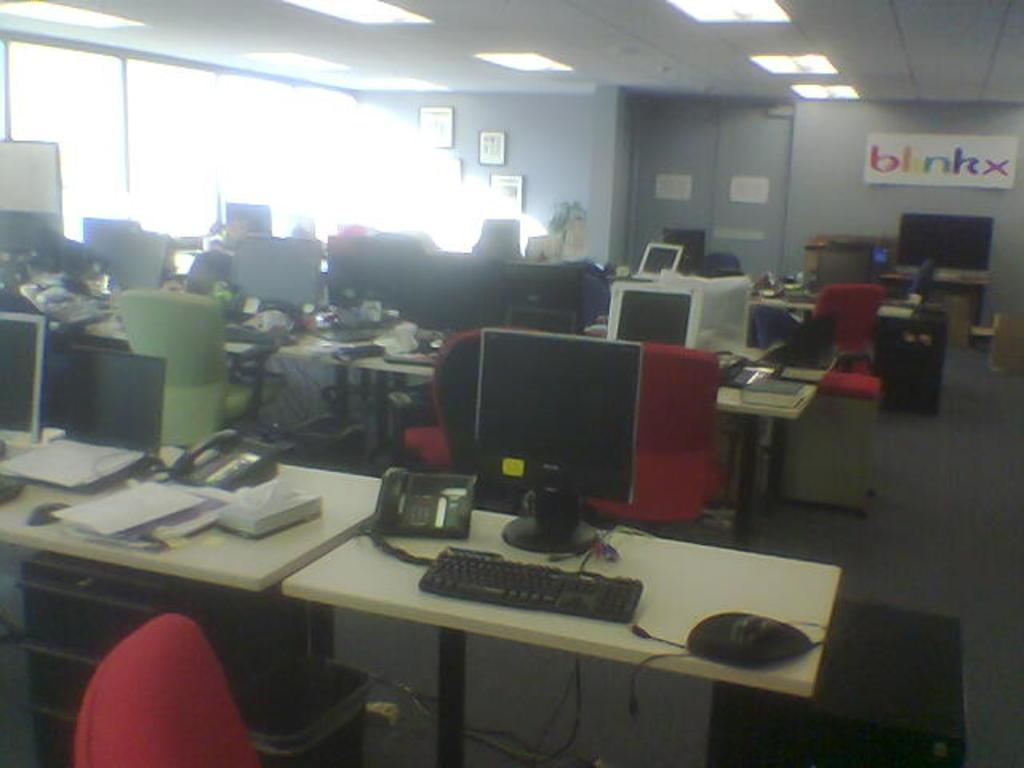<image>
Describe the image concisely. A look inside the empty offices of BlinkX 